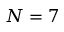Convert formula to latex. <formula><loc_0><loc_0><loc_500><loc_500>N = 7</formula> 